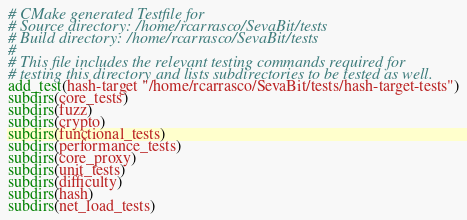<code> <loc_0><loc_0><loc_500><loc_500><_CMake_># CMake generated Testfile for 
# Source directory: /home/rcarrasco/SevaBit/tests
# Build directory: /home/rcarrasco/SevaBit/tests
# 
# This file includes the relevant testing commands required for 
# testing this directory and lists subdirectories to be tested as well.
add_test(hash-target "/home/rcarrasco/SevaBit/tests/hash-target-tests")
subdirs(core_tests)
subdirs(fuzz)
subdirs(crypto)
subdirs(functional_tests)
subdirs(performance_tests)
subdirs(core_proxy)
subdirs(unit_tests)
subdirs(difficulty)
subdirs(hash)
subdirs(net_load_tests)
</code> 